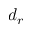<formula> <loc_0><loc_0><loc_500><loc_500>d _ { r }</formula> 